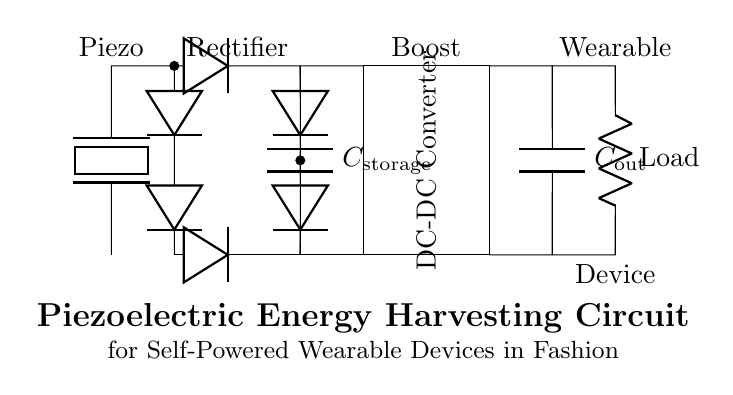What component is used for energy conversion? The component used for energy conversion in this circuit is the piezoelectric element, which transforms mechanical energy into electrical energy.
Answer: Piezoelectric What is the role of the storage capacitor? The storage capacitor is responsible for storing the electrical energy generated by the piezoelectric element after it has been rectified.
Answer: Storage capacitor How many diodes are present in the rectifier section? There are four diodes present in the rectifier section, configured to form a bridge rectifier for converting AC to DC.
Answer: Four What is the output voltage of the circuit? The output voltage can vary, but it is typically designed to be higher than the input generated by the piezoelectric element, achieved by the DC-DC converter.
Answer: Variable What does the load represent in this circuit? The load represents the wearable device that utilizes the harvested energy for its operation, illustrating the practical application of the circuit.
Answer: Wearable device What type of converter is utilized in this circuit? The type of converter utilized in this circuit is a DC-DC converter, which boosts the rectified voltage to a usable level for the wearable application.
Answer: Boost 